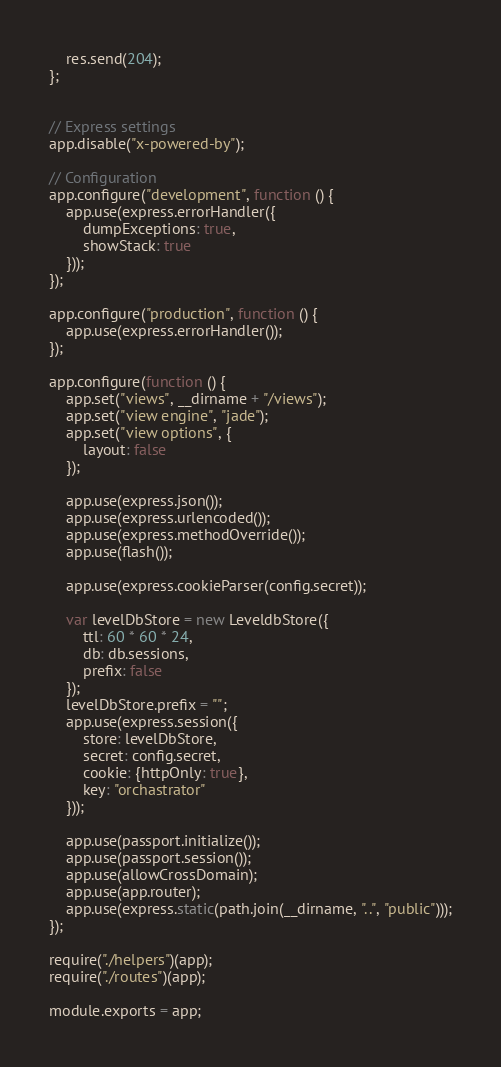<code> <loc_0><loc_0><loc_500><loc_500><_JavaScript_>
    res.send(204);
};


// Express settings
app.disable("x-powered-by");

// Configuration
app.configure("development", function () {
    app.use(express.errorHandler({
        dumpExceptions: true,
        showStack: true
    }));
});

app.configure("production", function () {
    app.use(express.errorHandler());
});

app.configure(function () {
    app.set("views", __dirname + "/views");
    app.set("view engine", "jade");
    app.set("view options", {
        layout: false
    });

    app.use(express.json());
    app.use(express.urlencoded());
    app.use(express.methodOverride());
    app.use(flash());

    app.use(express.cookieParser(config.secret));

    var levelDbStore = new LeveldbStore({
        ttl: 60 * 60 * 24,
        db: db.sessions,
        prefix: false
    });
    levelDbStore.prefix = "";
    app.use(express.session({
        store: levelDbStore,
        secret: config.secret,
        cookie: {httpOnly: true},
        key: "orchastrator"
    }));

    app.use(passport.initialize());
    app.use(passport.session());
    app.use(allowCrossDomain);
    app.use(app.router);
    app.use(express.static(path.join(__dirname, "..", "public")));
});

require("./helpers")(app);
require("./routes")(app);

module.exports = app;
</code> 